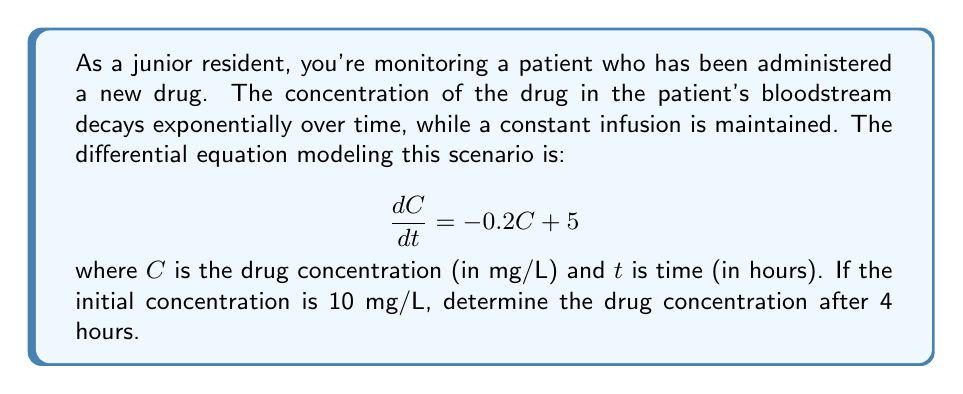Could you help me with this problem? To solve this first-order linear differential equation, we'll follow these steps:

1) The general form of a first-order linear differential equation is:

   $$\frac{dy}{dx} + P(x)y = Q(x)$$

   In our case, $\frac{dC}{dt} + 0.2C = 5$

2) The integrating factor is $e^{\int P(x)dx}$. Here, it's $e^{\int 0.2 dt} = e^{0.2t}$

3) Multiply both sides of the equation by the integrating factor:

   $$e^{0.2t}\frac{dC}{dt} + 0.2Ce^{0.2t} = 5e^{0.2t}$$

4) The left side is now the derivative of $Ce^{0.2t}$:

   $$\frac{d}{dt}(Ce^{0.2t}) = 5e^{0.2t}$$

5) Integrate both sides:

   $$Ce^{0.2t} = 25e^{0.2t} + K$$

6) Solve for C:

   $$C = 25 + Ke^{-0.2t}$$

7) Use the initial condition $C(0) = 10$ to find K:

   $$10 = 25 + K$$
   $$K = -15$$

8) The particular solution is:

   $$C = 25 - 15e^{-0.2t}$$

9) To find the concentration after 4 hours, substitute $t = 4$:

   $$C(4) = 25 - 15e^{-0.2(4)} = 25 - 15e^{-0.8}$$

10) Calculate the final result:

    $$C(4) = 25 - 15(0.4493) = 25 - 6.7395 = 18.2605$$
Answer: The drug concentration after 4 hours is approximately 18.26 mg/L. 